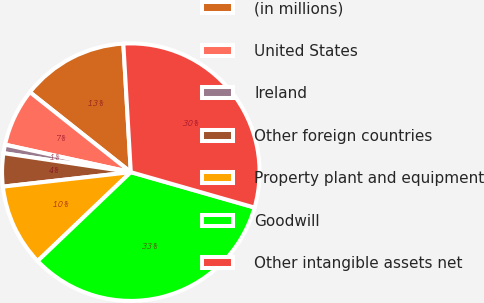Convert chart. <chart><loc_0><loc_0><loc_500><loc_500><pie_chart><fcel>(in millions)<fcel>United States<fcel>Ireland<fcel>Other foreign countries<fcel>Property plant and equipment<fcel>Goodwill<fcel>Other intangible assets net<nl><fcel>13.41%<fcel>7.24%<fcel>1.07%<fcel>4.15%<fcel>10.33%<fcel>33.44%<fcel>30.36%<nl></chart> 